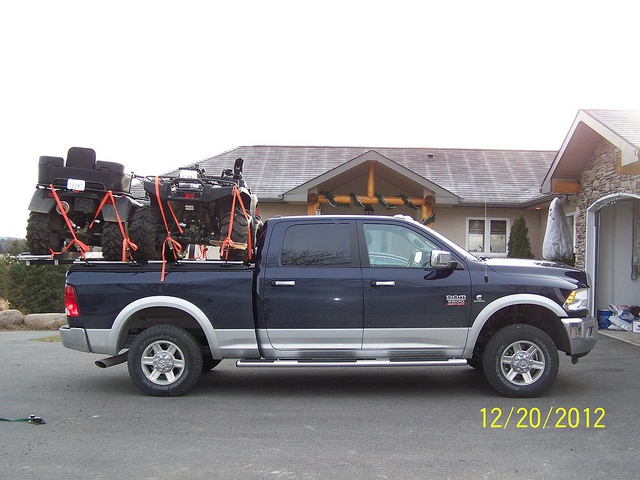Describe the objects in this image and their specific colors. I can see truck in white, gray, black, and darkgray tones and potted plant in white, black, and gray tones in this image. 